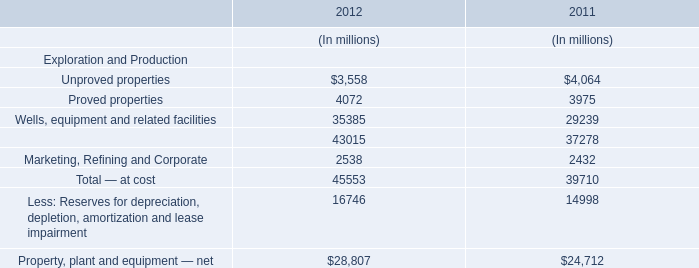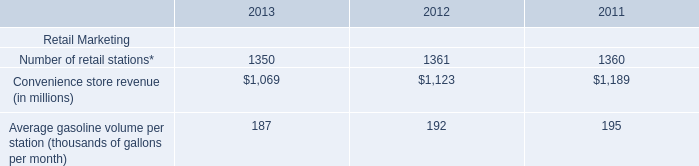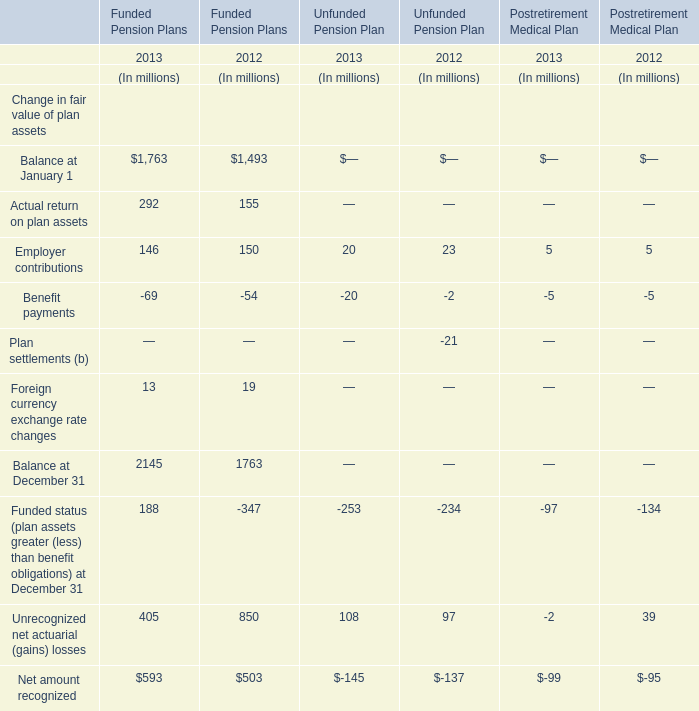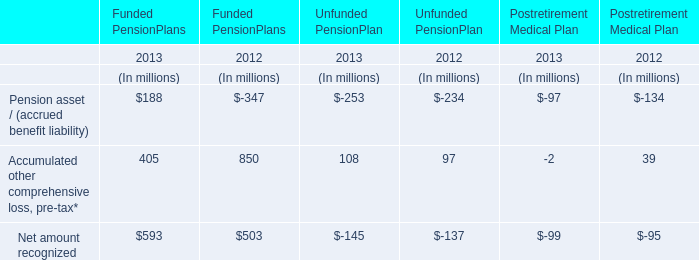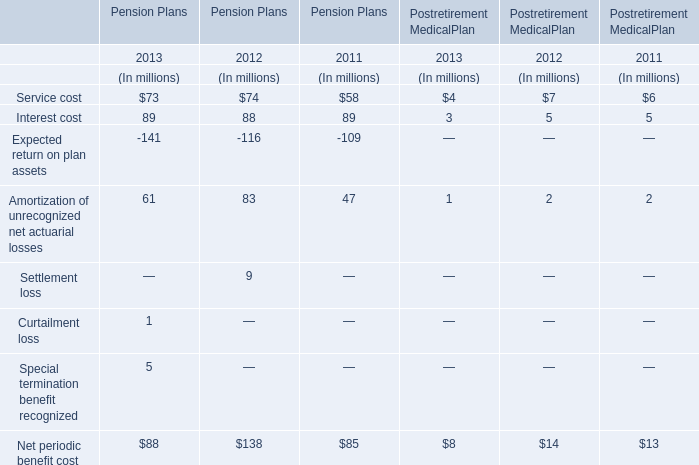In the section with lowest amount of Pension asset / (accrued benefit liability), what's the increasing rate of Accumulated other comprehensive loss, pre-tax*? 
Computations: ((108 - 97) / 97)
Answer: 0.1134. 